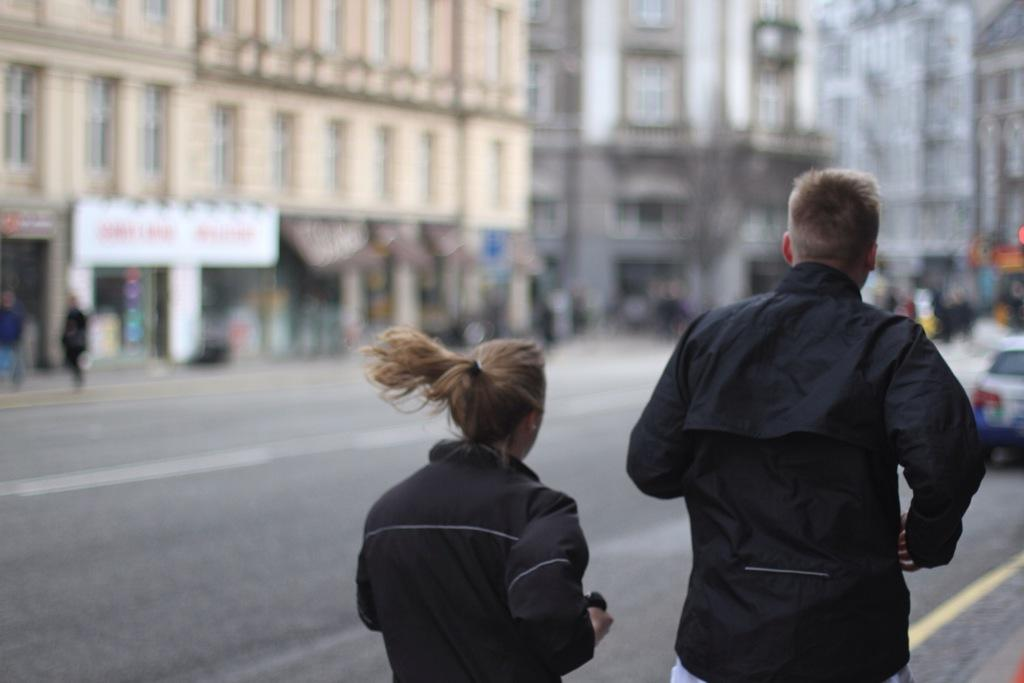How many people are in the image? There are two people in the image. What is located in front of the people? Buildings, people, a vehicle, and some objects are in front of the people. Can you describe the background of the image? The background of the image is blurry. What invention can be seen being used by the people in the image? There is no specific invention visible in the image; it only shows people, buildings, and other objects. What type of ear is visible on the people in the image? The image does not show any ears, as it focuses on the people and their surroundings. 